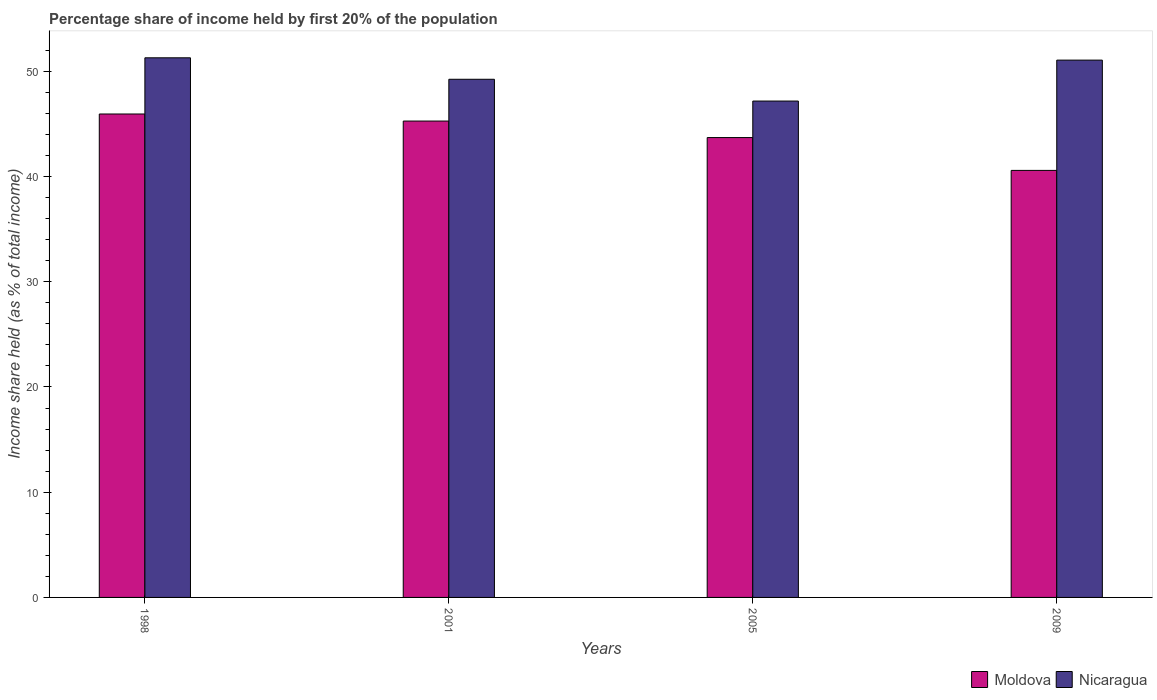How many different coloured bars are there?
Provide a short and direct response. 2. How many groups of bars are there?
Provide a succinct answer. 4. Are the number of bars per tick equal to the number of legend labels?
Your answer should be compact. Yes. How many bars are there on the 4th tick from the left?
Make the answer very short. 2. How many bars are there on the 4th tick from the right?
Provide a short and direct response. 2. What is the label of the 1st group of bars from the left?
Your answer should be compact. 1998. In how many cases, is the number of bars for a given year not equal to the number of legend labels?
Offer a terse response. 0. What is the share of income held by first 20% of the population in Moldova in 2005?
Provide a short and direct response. 43.7. Across all years, what is the maximum share of income held by first 20% of the population in Nicaragua?
Your answer should be compact. 51.28. Across all years, what is the minimum share of income held by first 20% of the population in Moldova?
Provide a short and direct response. 40.58. In which year was the share of income held by first 20% of the population in Moldova maximum?
Ensure brevity in your answer.  1998. In which year was the share of income held by first 20% of the population in Nicaragua minimum?
Provide a short and direct response. 2005. What is the total share of income held by first 20% of the population in Nicaragua in the graph?
Your answer should be compact. 198.75. What is the difference between the share of income held by first 20% of the population in Moldova in 1998 and that in 2001?
Ensure brevity in your answer.  0.67. What is the difference between the share of income held by first 20% of the population in Nicaragua in 1998 and the share of income held by first 20% of the population in Moldova in 2001?
Ensure brevity in your answer.  6.01. What is the average share of income held by first 20% of the population in Nicaragua per year?
Offer a very short reply. 49.69. In the year 2001, what is the difference between the share of income held by first 20% of the population in Moldova and share of income held by first 20% of the population in Nicaragua?
Provide a short and direct response. -3.97. In how many years, is the share of income held by first 20% of the population in Moldova greater than 50 %?
Give a very brief answer. 0. What is the ratio of the share of income held by first 20% of the population in Nicaragua in 2001 to that in 2005?
Offer a very short reply. 1.04. Is the difference between the share of income held by first 20% of the population in Moldova in 2005 and 2009 greater than the difference between the share of income held by first 20% of the population in Nicaragua in 2005 and 2009?
Ensure brevity in your answer.  Yes. What is the difference between the highest and the second highest share of income held by first 20% of the population in Nicaragua?
Provide a short and direct response. 0.22. What is the difference between the highest and the lowest share of income held by first 20% of the population in Moldova?
Ensure brevity in your answer.  5.36. Is the sum of the share of income held by first 20% of the population in Moldova in 2001 and 2005 greater than the maximum share of income held by first 20% of the population in Nicaragua across all years?
Your answer should be very brief. Yes. What does the 1st bar from the left in 1998 represents?
Ensure brevity in your answer.  Moldova. What does the 2nd bar from the right in 1998 represents?
Your response must be concise. Moldova. How many bars are there?
Your response must be concise. 8. Are all the bars in the graph horizontal?
Provide a short and direct response. No. How many years are there in the graph?
Your response must be concise. 4. Does the graph contain any zero values?
Offer a very short reply. No. What is the title of the graph?
Your answer should be compact. Percentage share of income held by first 20% of the population. Does "Iraq" appear as one of the legend labels in the graph?
Keep it short and to the point. No. What is the label or title of the X-axis?
Keep it short and to the point. Years. What is the label or title of the Y-axis?
Offer a very short reply. Income share held (as % of total income). What is the Income share held (as % of total income) of Moldova in 1998?
Your answer should be very brief. 45.94. What is the Income share held (as % of total income) in Nicaragua in 1998?
Ensure brevity in your answer.  51.28. What is the Income share held (as % of total income) of Moldova in 2001?
Your answer should be very brief. 45.27. What is the Income share held (as % of total income) in Nicaragua in 2001?
Offer a terse response. 49.24. What is the Income share held (as % of total income) in Moldova in 2005?
Offer a terse response. 43.7. What is the Income share held (as % of total income) in Nicaragua in 2005?
Your answer should be very brief. 47.17. What is the Income share held (as % of total income) of Moldova in 2009?
Your answer should be very brief. 40.58. What is the Income share held (as % of total income) in Nicaragua in 2009?
Offer a terse response. 51.06. Across all years, what is the maximum Income share held (as % of total income) of Moldova?
Give a very brief answer. 45.94. Across all years, what is the maximum Income share held (as % of total income) in Nicaragua?
Give a very brief answer. 51.28. Across all years, what is the minimum Income share held (as % of total income) of Moldova?
Offer a very short reply. 40.58. Across all years, what is the minimum Income share held (as % of total income) in Nicaragua?
Your answer should be very brief. 47.17. What is the total Income share held (as % of total income) of Moldova in the graph?
Your answer should be very brief. 175.49. What is the total Income share held (as % of total income) of Nicaragua in the graph?
Ensure brevity in your answer.  198.75. What is the difference between the Income share held (as % of total income) of Moldova in 1998 and that in 2001?
Your response must be concise. 0.67. What is the difference between the Income share held (as % of total income) of Nicaragua in 1998 and that in 2001?
Your answer should be very brief. 2.04. What is the difference between the Income share held (as % of total income) of Moldova in 1998 and that in 2005?
Provide a succinct answer. 2.24. What is the difference between the Income share held (as % of total income) of Nicaragua in 1998 and that in 2005?
Provide a succinct answer. 4.11. What is the difference between the Income share held (as % of total income) in Moldova in 1998 and that in 2009?
Offer a very short reply. 5.36. What is the difference between the Income share held (as % of total income) of Nicaragua in 1998 and that in 2009?
Provide a short and direct response. 0.22. What is the difference between the Income share held (as % of total income) in Moldova in 2001 and that in 2005?
Make the answer very short. 1.57. What is the difference between the Income share held (as % of total income) in Nicaragua in 2001 and that in 2005?
Ensure brevity in your answer.  2.07. What is the difference between the Income share held (as % of total income) in Moldova in 2001 and that in 2009?
Offer a terse response. 4.69. What is the difference between the Income share held (as % of total income) of Nicaragua in 2001 and that in 2009?
Your response must be concise. -1.82. What is the difference between the Income share held (as % of total income) of Moldova in 2005 and that in 2009?
Provide a short and direct response. 3.12. What is the difference between the Income share held (as % of total income) of Nicaragua in 2005 and that in 2009?
Offer a very short reply. -3.89. What is the difference between the Income share held (as % of total income) of Moldova in 1998 and the Income share held (as % of total income) of Nicaragua in 2001?
Your response must be concise. -3.3. What is the difference between the Income share held (as % of total income) of Moldova in 1998 and the Income share held (as % of total income) of Nicaragua in 2005?
Provide a succinct answer. -1.23. What is the difference between the Income share held (as % of total income) in Moldova in 1998 and the Income share held (as % of total income) in Nicaragua in 2009?
Your answer should be very brief. -5.12. What is the difference between the Income share held (as % of total income) of Moldova in 2001 and the Income share held (as % of total income) of Nicaragua in 2005?
Offer a very short reply. -1.9. What is the difference between the Income share held (as % of total income) in Moldova in 2001 and the Income share held (as % of total income) in Nicaragua in 2009?
Your answer should be very brief. -5.79. What is the difference between the Income share held (as % of total income) in Moldova in 2005 and the Income share held (as % of total income) in Nicaragua in 2009?
Offer a very short reply. -7.36. What is the average Income share held (as % of total income) in Moldova per year?
Your answer should be very brief. 43.87. What is the average Income share held (as % of total income) of Nicaragua per year?
Your answer should be very brief. 49.69. In the year 1998, what is the difference between the Income share held (as % of total income) of Moldova and Income share held (as % of total income) of Nicaragua?
Make the answer very short. -5.34. In the year 2001, what is the difference between the Income share held (as % of total income) in Moldova and Income share held (as % of total income) in Nicaragua?
Your response must be concise. -3.97. In the year 2005, what is the difference between the Income share held (as % of total income) of Moldova and Income share held (as % of total income) of Nicaragua?
Make the answer very short. -3.47. In the year 2009, what is the difference between the Income share held (as % of total income) in Moldova and Income share held (as % of total income) in Nicaragua?
Ensure brevity in your answer.  -10.48. What is the ratio of the Income share held (as % of total income) in Moldova in 1998 to that in 2001?
Provide a succinct answer. 1.01. What is the ratio of the Income share held (as % of total income) in Nicaragua in 1998 to that in 2001?
Ensure brevity in your answer.  1.04. What is the ratio of the Income share held (as % of total income) of Moldova in 1998 to that in 2005?
Provide a succinct answer. 1.05. What is the ratio of the Income share held (as % of total income) of Nicaragua in 1998 to that in 2005?
Keep it short and to the point. 1.09. What is the ratio of the Income share held (as % of total income) of Moldova in 1998 to that in 2009?
Give a very brief answer. 1.13. What is the ratio of the Income share held (as % of total income) of Moldova in 2001 to that in 2005?
Offer a terse response. 1.04. What is the ratio of the Income share held (as % of total income) of Nicaragua in 2001 to that in 2005?
Ensure brevity in your answer.  1.04. What is the ratio of the Income share held (as % of total income) of Moldova in 2001 to that in 2009?
Give a very brief answer. 1.12. What is the ratio of the Income share held (as % of total income) of Nicaragua in 2001 to that in 2009?
Make the answer very short. 0.96. What is the ratio of the Income share held (as % of total income) in Moldova in 2005 to that in 2009?
Provide a short and direct response. 1.08. What is the ratio of the Income share held (as % of total income) in Nicaragua in 2005 to that in 2009?
Your answer should be compact. 0.92. What is the difference between the highest and the second highest Income share held (as % of total income) in Moldova?
Offer a very short reply. 0.67. What is the difference between the highest and the second highest Income share held (as % of total income) of Nicaragua?
Provide a succinct answer. 0.22. What is the difference between the highest and the lowest Income share held (as % of total income) of Moldova?
Offer a terse response. 5.36. What is the difference between the highest and the lowest Income share held (as % of total income) in Nicaragua?
Provide a short and direct response. 4.11. 